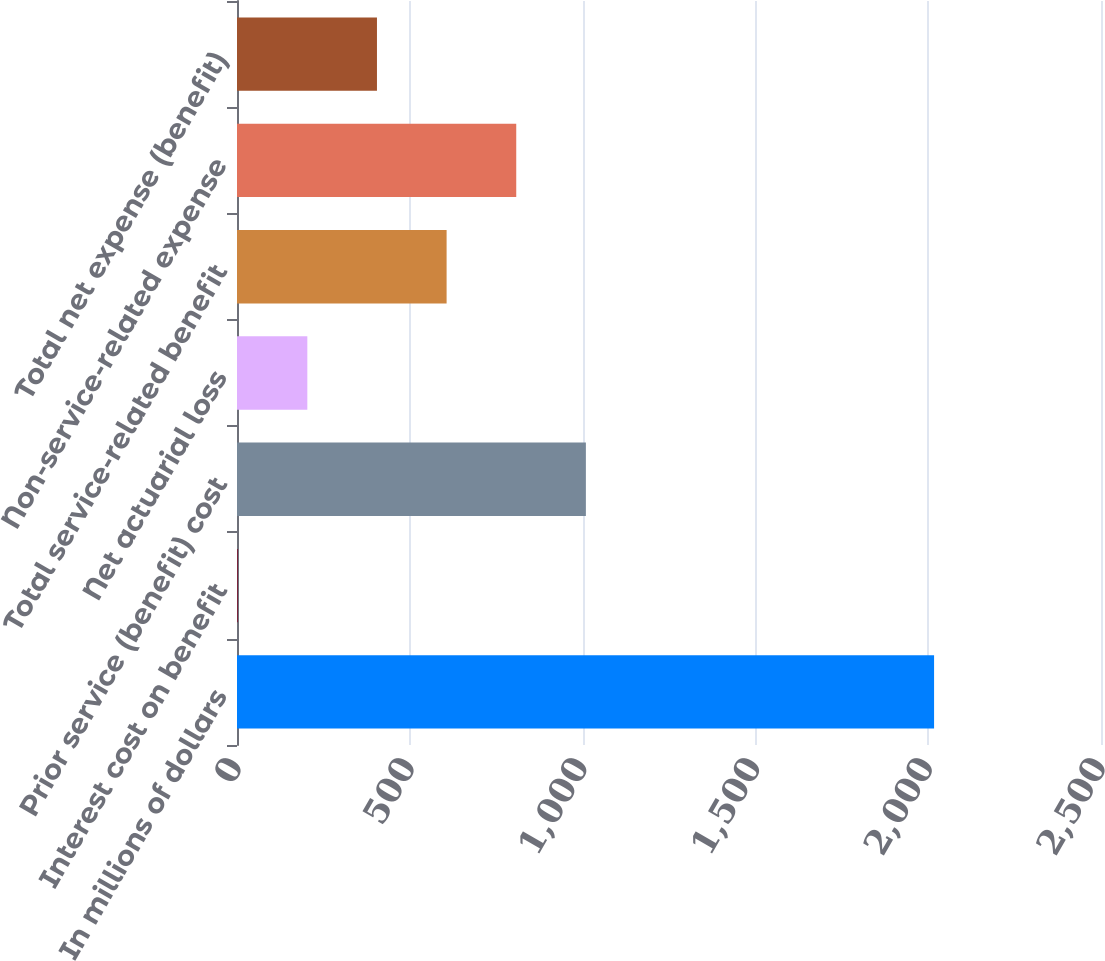Convert chart. <chart><loc_0><loc_0><loc_500><loc_500><bar_chart><fcel>In millions of dollars<fcel>Interest cost on benefit<fcel>Prior service (benefit) cost<fcel>Net actuarial loss<fcel>Total service-related benefit<fcel>Non-service-related expense<fcel>Total net expense (benefit)<nl><fcel>2017<fcel>2<fcel>1009.5<fcel>203.5<fcel>606.5<fcel>808<fcel>405<nl></chart> 